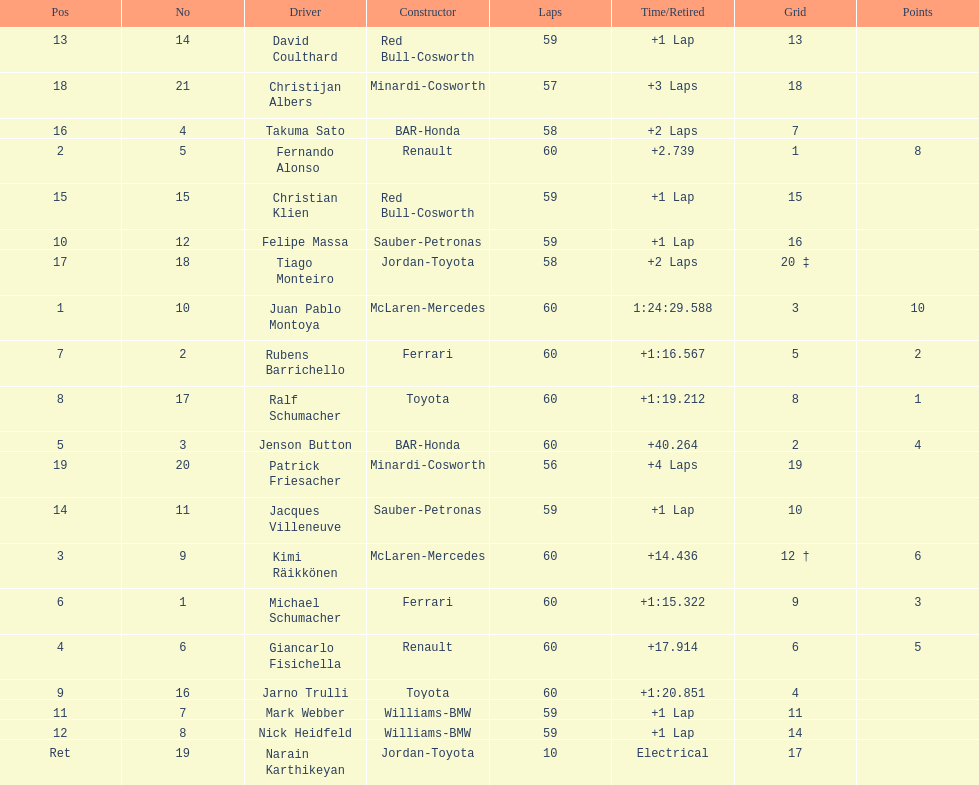What is the number of toyota's on the list? 4. Could you parse the entire table as a dict? {'header': ['Pos', 'No', 'Driver', 'Constructor', 'Laps', 'Time/Retired', 'Grid', 'Points'], 'rows': [['13', '14', 'David Coulthard', 'Red Bull-Cosworth', '59', '+1 Lap', '13', ''], ['18', '21', 'Christijan Albers', 'Minardi-Cosworth', '57', '+3 Laps', '18', ''], ['16', '4', 'Takuma Sato', 'BAR-Honda', '58', '+2 Laps', '7', ''], ['2', '5', 'Fernando Alonso', 'Renault', '60', '+2.739', '1', '8'], ['15', '15', 'Christian Klien', 'Red Bull-Cosworth', '59', '+1 Lap', '15', ''], ['10', '12', 'Felipe Massa', 'Sauber-Petronas', '59', '+1 Lap', '16', ''], ['17', '18', 'Tiago Monteiro', 'Jordan-Toyota', '58', '+2 Laps', '20 ‡', ''], ['1', '10', 'Juan Pablo Montoya', 'McLaren-Mercedes', '60', '1:24:29.588', '3', '10'], ['7', '2', 'Rubens Barrichello', 'Ferrari', '60', '+1:16.567', '5', '2'], ['8', '17', 'Ralf Schumacher', 'Toyota', '60', '+1:19.212', '8', '1'], ['5', '3', 'Jenson Button', 'BAR-Honda', '60', '+40.264', '2', '4'], ['19', '20', 'Patrick Friesacher', 'Minardi-Cosworth', '56', '+4 Laps', '19', ''], ['14', '11', 'Jacques Villeneuve', 'Sauber-Petronas', '59', '+1 Lap', '10', ''], ['3', '9', 'Kimi Räikkönen', 'McLaren-Mercedes', '60', '+14.436', '12 †', '6'], ['6', '1', 'Michael Schumacher', 'Ferrari', '60', '+1:15.322', '9', '3'], ['4', '6', 'Giancarlo Fisichella', 'Renault', '60', '+17.914', '6', '5'], ['9', '16', 'Jarno Trulli', 'Toyota', '60', '+1:20.851', '4', ''], ['11', '7', 'Mark Webber', 'Williams-BMW', '59', '+1 Lap', '11', ''], ['12', '8', 'Nick Heidfeld', 'Williams-BMW', '59', '+1 Lap', '14', ''], ['Ret', '19', 'Narain Karthikeyan', 'Jordan-Toyota', '10', 'Electrical', '17', '']]} 